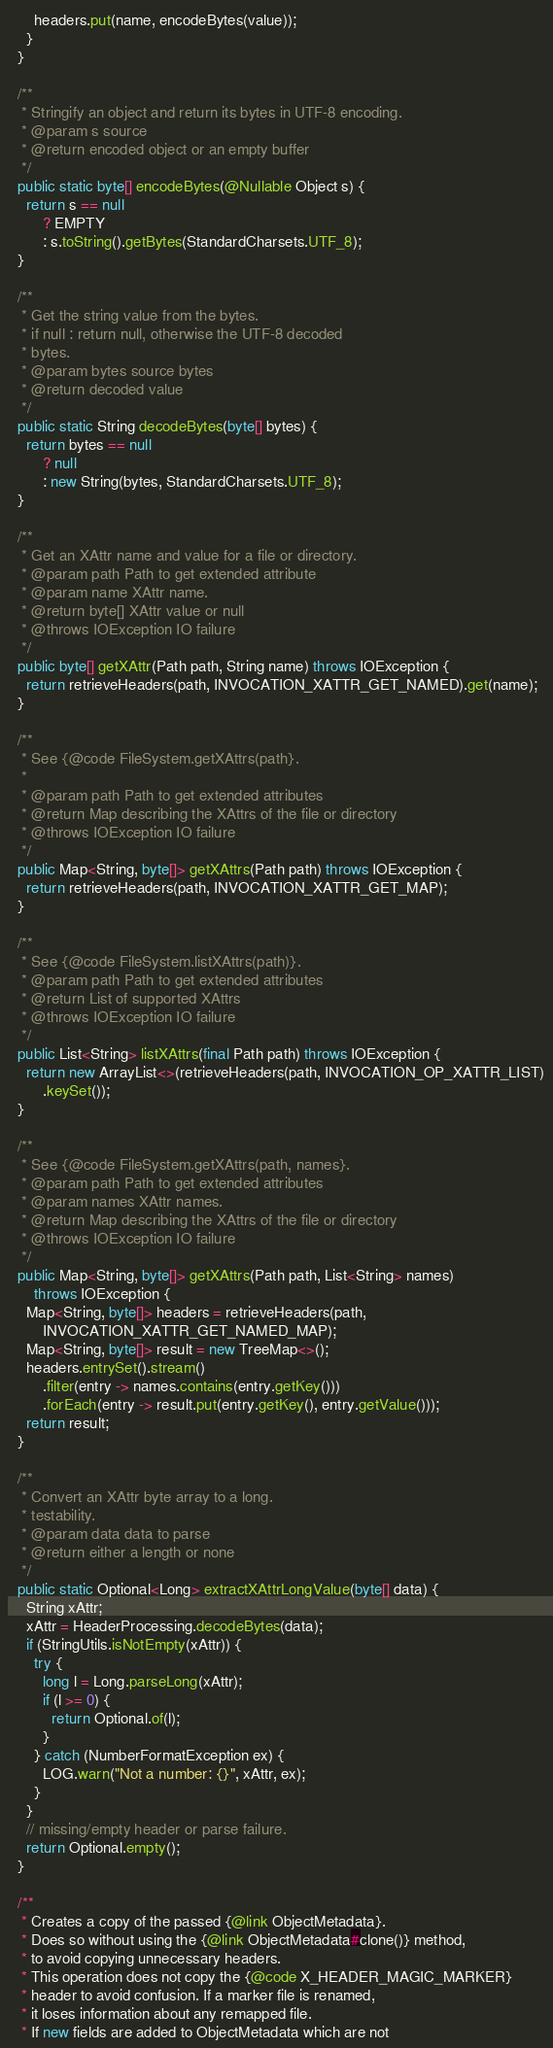Convert code to text. <code><loc_0><loc_0><loc_500><loc_500><_Java_>      headers.put(name, encodeBytes(value));
    }
  }

  /**
   * Stringify an object and return its bytes in UTF-8 encoding.
   * @param s source
   * @return encoded object or an empty buffer
   */
  public static byte[] encodeBytes(@Nullable Object s) {
    return s == null
        ? EMPTY
        : s.toString().getBytes(StandardCharsets.UTF_8);
  }

  /**
   * Get the string value from the bytes.
   * if null : return null, otherwise the UTF-8 decoded
   * bytes.
   * @param bytes source bytes
   * @return decoded value
   */
  public static String decodeBytes(byte[] bytes) {
    return bytes == null
        ? null
        : new String(bytes, StandardCharsets.UTF_8);
  }

  /**
   * Get an XAttr name and value for a file or directory.
   * @param path Path to get extended attribute
   * @param name XAttr name.
   * @return byte[] XAttr value or null
   * @throws IOException IO failure
   */
  public byte[] getXAttr(Path path, String name) throws IOException {
    return retrieveHeaders(path, INVOCATION_XATTR_GET_NAMED).get(name);
  }

  /**
   * See {@code FileSystem.getXAttrs(path}.
   *
   * @param path Path to get extended attributes
   * @return Map describing the XAttrs of the file or directory
   * @throws IOException IO failure
   */
  public Map<String, byte[]> getXAttrs(Path path) throws IOException {
    return retrieveHeaders(path, INVOCATION_XATTR_GET_MAP);
  }

  /**
   * See {@code FileSystem.listXAttrs(path)}.
   * @param path Path to get extended attributes
   * @return List of supported XAttrs
   * @throws IOException IO failure
   */
  public List<String> listXAttrs(final Path path) throws IOException {
    return new ArrayList<>(retrieveHeaders(path, INVOCATION_OP_XATTR_LIST)
        .keySet());
  }

  /**
   * See {@code FileSystem.getXAttrs(path, names}.
   * @param path Path to get extended attributes
   * @param names XAttr names.
   * @return Map describing the XAttrs of the file or directory
   * @throws IOException IO failure
   */
  public Map<String, byte[]> getXAttrs(Path path, List<String> names)
      throws IOException {
    Map<String, byte[]> headers = retrieveHeaders(path,
        INVOCATION_XATTR_GET_NAMED_MAP);
    Map<String, byte[]> result = new TreeMap<>();
    headers.entrySet().stream()
        .filter(entry -> names.contains(entry.getKey()))
        .forEach(entry -> result.put(entry.getKey(), entry.getValue()));
    return result;
  }

  /**
   * Convert an XAttr byte array to a long.
   * testability.
   * @param data data to parse
   * @return either a length or none
   */
  public static Optional<Long> extractXAttrLongValue(byte[] data) {
    String xAttr;
    xAttr = HeaderProcessing.decodeBytes(data);
    if (StringUtils.isNotEmpty(xAttr)) {
      try {
        long l = Long.parseLong(xAttr);
        if (l >= 0) {
          return Optional.of(l);
        }
      } catch (NumberFormatException ex) {
        LOG.warn("Not a number: {}", xAttr, ex);
      }
    }
    // missing/empty header or parse failure.
    return Optional.empty();
  }

  /**
   * Creates a copy of the passed {@link ObjectMetadata}.
   * Does so without using the {@link ObjectMetadata#clone()} method,
   * to avoid copying unnecessary headers.
   * This operation does not copy the {@code X_HEADER_MAGIC_MARKER}
   * header to avoid confusion. If a marker file is renamed,
   * it loses information about any remapped file.
   * If new fields are added to ObjectMetadata which are not</code> 